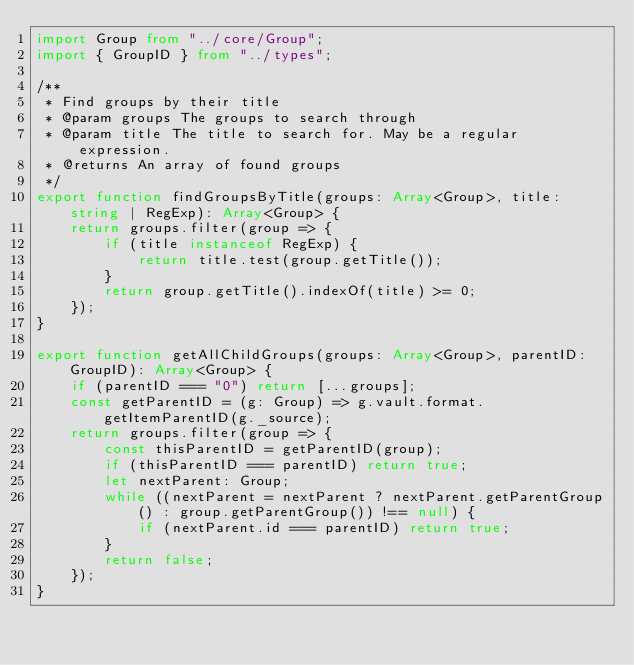<code> <loc_0><loc_0><loc_500><loc_500><_TypeScript_>import Group from "../core/Group";
import { GroupID } from "../types";

/**
 * Find groups by their title
 * @param groups The groups to search through
 * @param title The title to search for. May be a regular expression.
 * @returns An array of found groups
 */
export function findGroupsByTitle(groups: Array<Group>, title: string | RegExp): Array<Group> {
    return groups.filter(group => {
        if (title instanceof RegExp) {
            return title.test(group.getTitle());
        }
        return group.getTitle().indexOf(title) >= 0;
    });
}

export function getAllChildGroups(groups: Array<Group>, parentID: GroupID): Array<Group> {
    if (parentID === "0") return [...groups];
    const getParentID = (g: Group) => g.vault.format.getItemParentID(g._source);
    return groups.filter(group => {
        const thisParentID = getParentID(group);
        if (thisParentID === parentID) return true;
        let nextParent: Group;
        while ((nextParent = nextParent ? nextParent.getParentGroup() : group.getParentGroup()) !== null) {
            if (nextParent.id === parentID) return true;
        }
        return false;
    });
}
</code> 